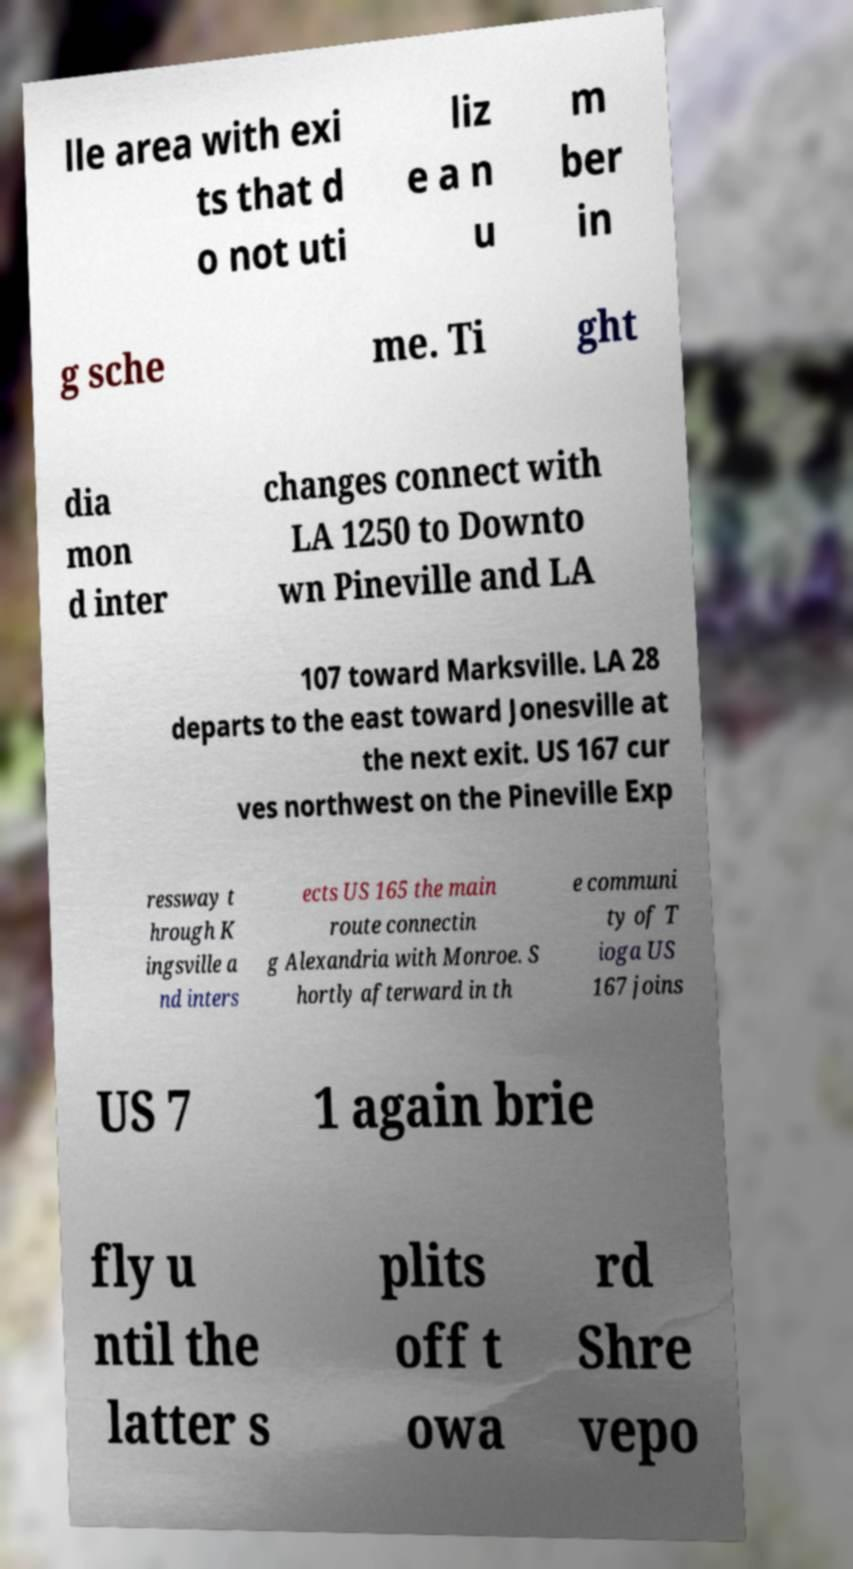Can you accurately transcribe the text from the provided image for me? lle area with exi ts that d o not uti liz e a n u m ber in g sche me. Ti ght dia mon d inter changes connect with LA 1250 to Downto wn Pineville and LA 107 toward Marksville. LA 28 departs to the east toward Jonesville at the next exit. US 167 cur ves northwest on the Pineville Exp ressway t hrough K ingsville a nd inters ects US 165 the main route connectin g Alexandria with Monroe. S hortly afterward in th e communi ty of T ioga US 167 joins US 7 1 again brie fly u ntil the latter s plits off t owa rd Shre vepo 